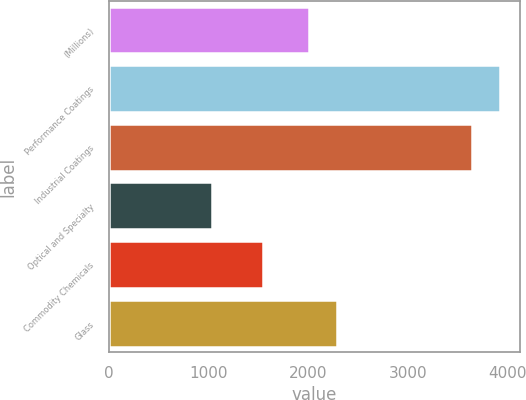Convert chart. <chart><loc_0><loc_0><loc_500><loc_500><bar_chart><fcel>(Millions)<fcel>Performance Coatings<fcel>Industrial Coatings<fcel>Optical and Specialty<fcel>Commodity Chemicals<fcel>Glass<nl><fcel>2007<fcel>3924.2<fcel>3646<fcel>1029<fcel>1539<fcel>2285.2<nl></chart> 